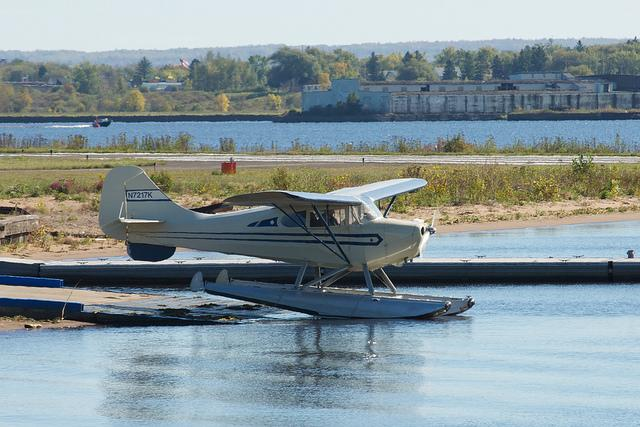What class of aircraft is seen here? amphibious 